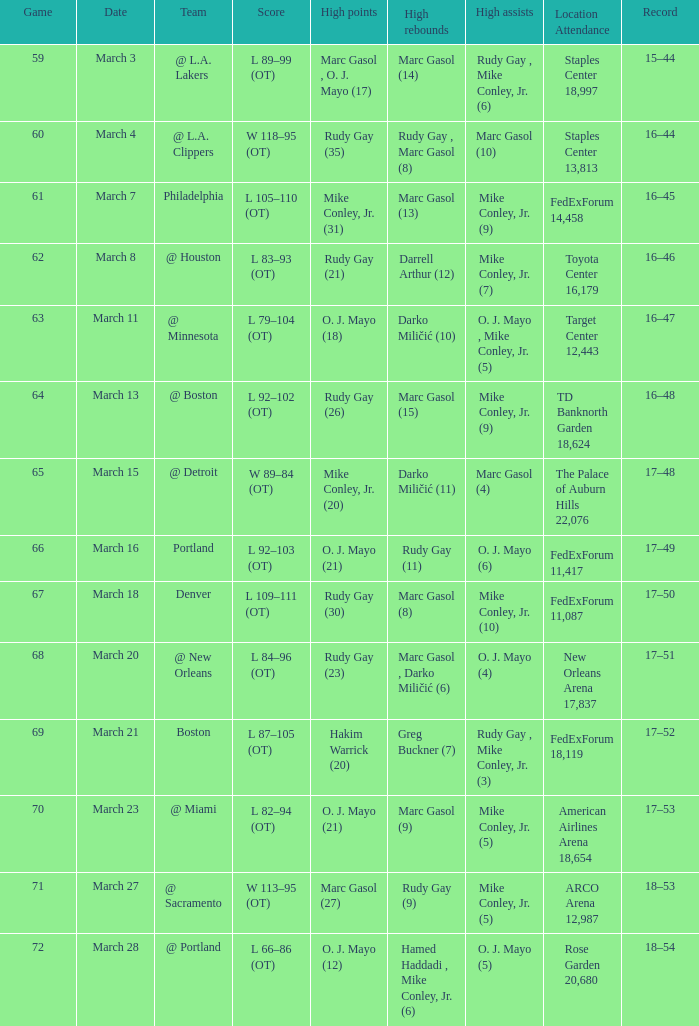What was the location and attendance for game 60? Staples Center 13,813. 